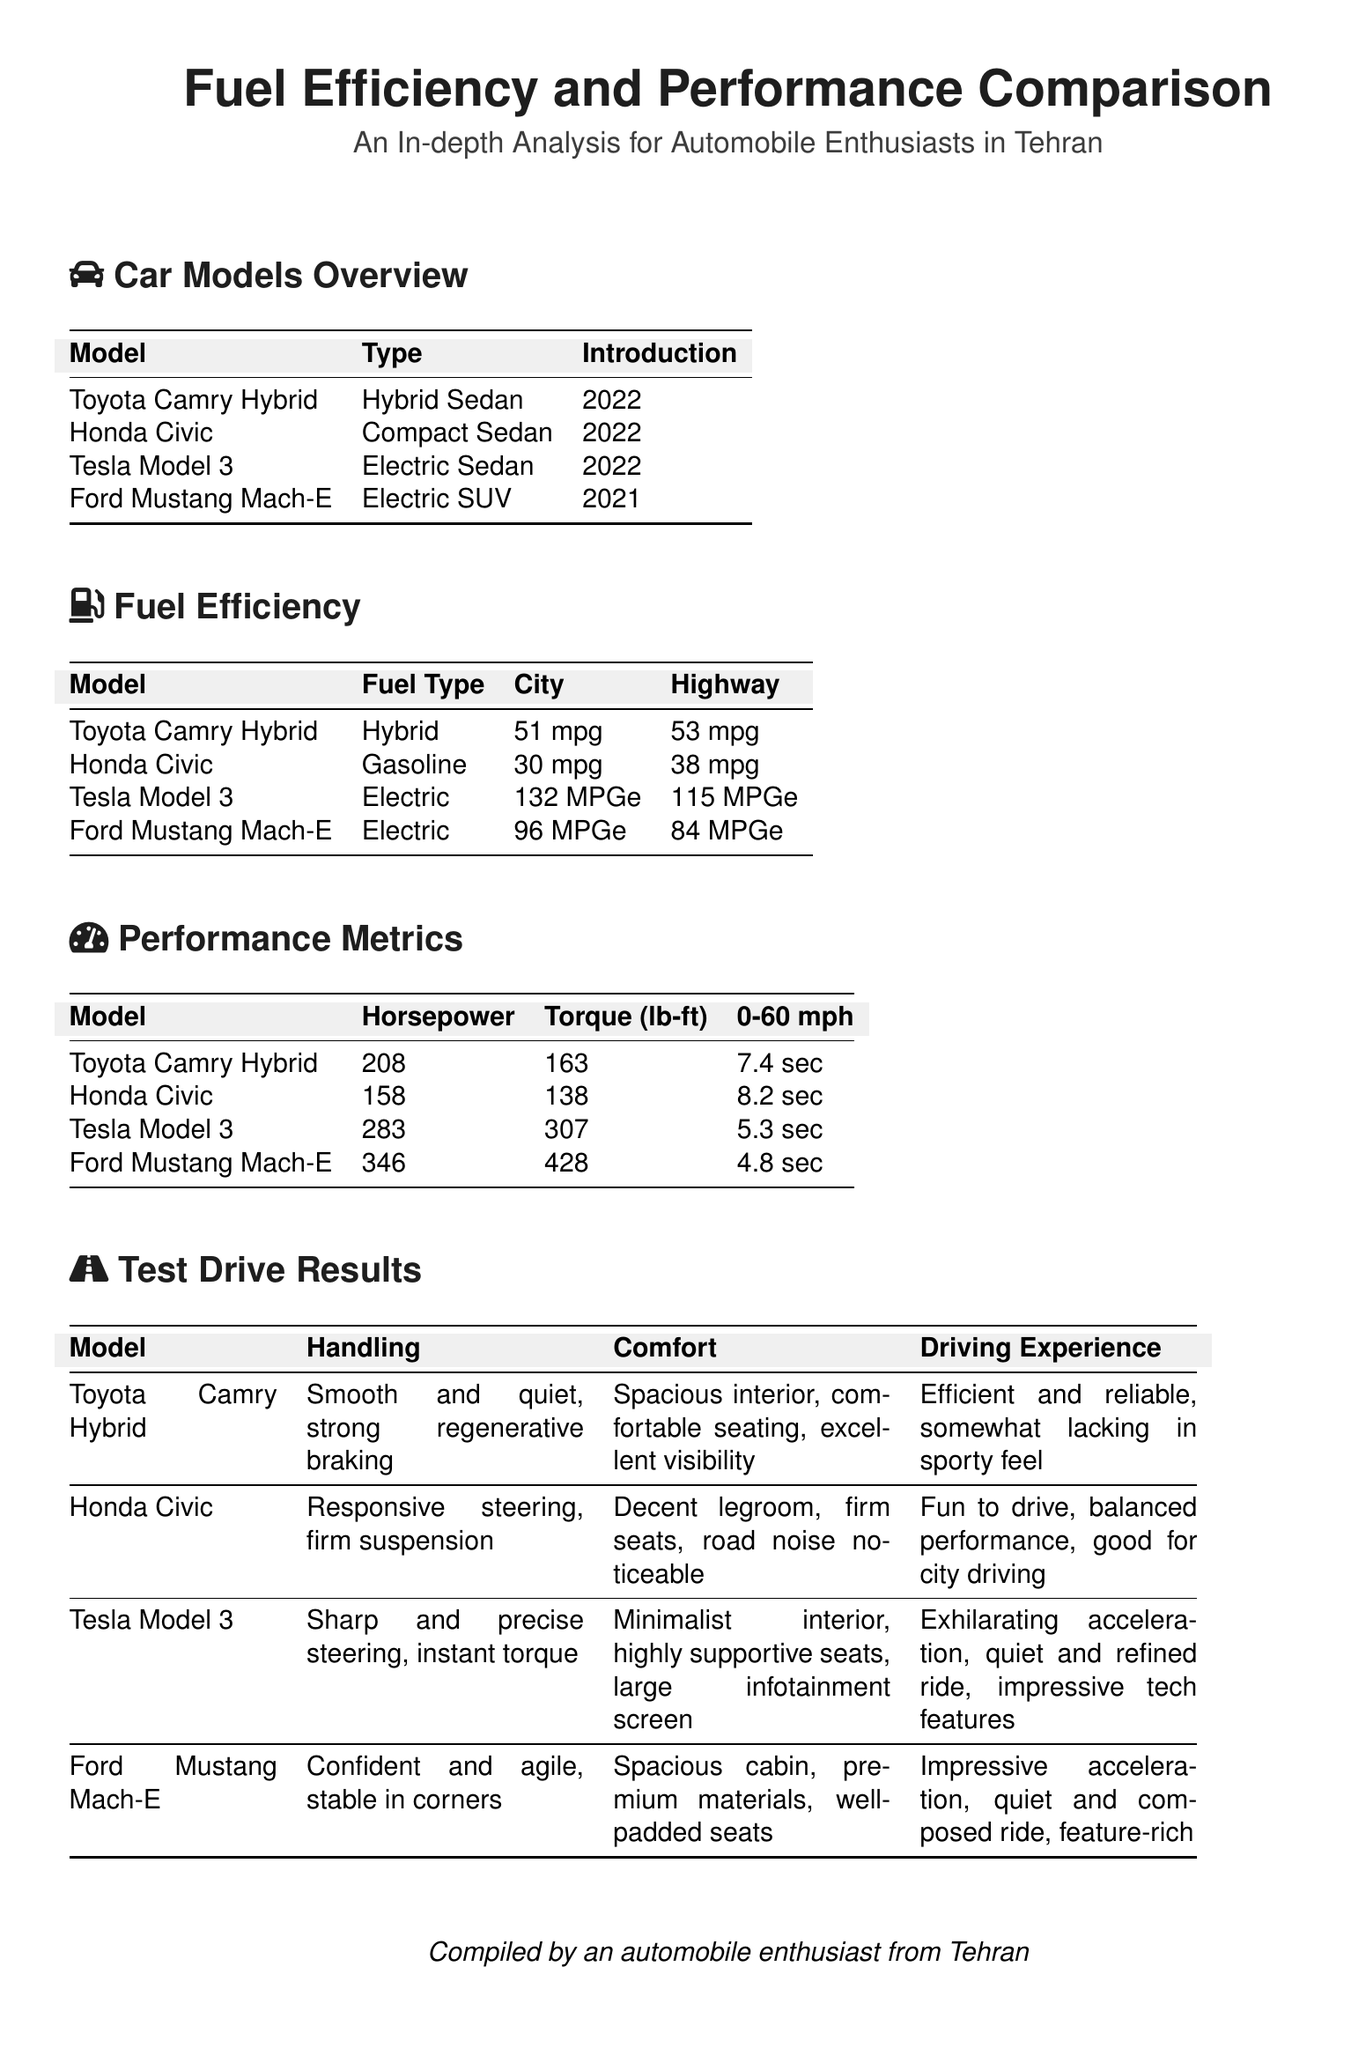What is the fuel efficiency of the Toyota Camry Hybrid in the city? The city fuel efficiency of the Toyota Camry Hybrid is found in the Fuel Efficiency section of the document, which states it is 51 mpg.
Answer: 51 mpg What type of vehicle is the Ford Mustang Mach-E? The type of vehicle for the Ford Mustang Mach-E is listed in the Car Models Overview section, identifying it as an Electric SUV.
Answer: Electric SUV What is the horsepower of the Honda Civic? The horsepower of the Honda Civic can be found in the Performance Metrics section, where it is mentioned to be 158.
Answer: 158 Which model has the best acceleration from 0-60 mph? The model that has the best acceleration from 0-60 mph can be determined by comparing values in the Performance Metrics section; the Ford Mustang Mach-E is noted at 4.8 seconds.
Answer: Ford Mustang Mach-E What is the driving experience description for the Tesla Model 3? The driving experience for the Tesla Model 3 is outlined in the Test Drive Results, which describes it as exhilarating acceleration, quiet and refined ride, impressive tech features.
Answer: Exhilarating acceleration, quiet and refined ride, impressive tech features What fuel type does the Honda Civic use? The fuel type for the Honda Civic is detailed in the Fuel Efficiency section, indicating that it uses gasoline.
Answer: Gasoline Which car has the highest torque rating? To find out which car has the highest torque rating, we look at the Performance Metrics section, where the Ford Mustang Mach-E shows a torque of 428 lb-ft, the highest.
Answer: Ford Mustang Mach-E What year was the Tesla Model 3 introduced? The introduction year for the Tesla Model 3 is included in the Car Models Overview section, which states it was introduced in 2022.
Answer: 2022 